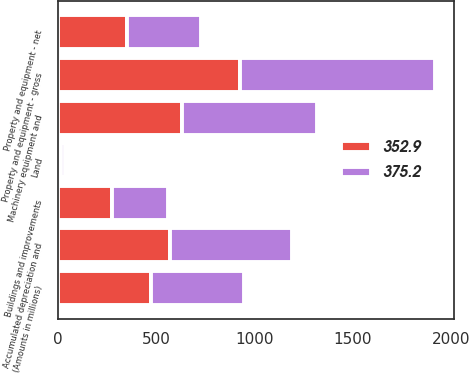Convert chart. <chart><loc_0><loc_0><loc_500><loc_500><stacked_bar_chart><ecel><fcel>(Amounts in millions)<fcel>Land<fcel>Buildings and improvements<fcel>Machinery equipment and<fcel>Property and equipment - gross<fcel>Accumulated depreciation and<fcel>Property and equipment - net<nl><fcel>375.2<fcel>474.65<fcel>19.4<fcel>286.2<fcel>684.6<fcel>990.2<fcel>615<fcel>375.2<nl><fcel>352.9<fcel>474.65<fcel>19.8<fcel>274.9<fcel>632.3<fcel>927<fcel>574.1<fcel>352.9<nl></chart> 